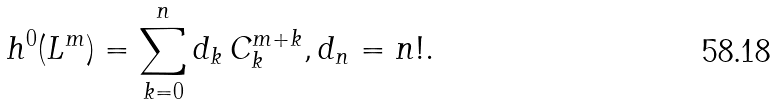Convert formula to latex. <formula><loc_0><loc_0><loc_500><loc_500>h ^ { 0 } ( L ^ { m } ) = \sum _ { k = 0 } ^ { n } d _ { k } \, C _ { k } ^ { m + k } , d _ { n } = n ! .</formula> 